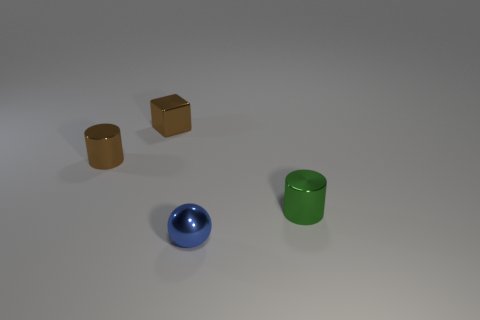Subtract all green cylinders. How many cylinders are left? 1 Subtract 2 cylinders. How many cylinders are left? 0 Add 3 small brown things. How many objects exist? 7 Subtract 1 brown cubes. How many objects are left? 3 Subtract all blue blocks. Subtract all blue cylinders. How many blocks are left? 1 Subtract all red cylinders. How many red cubes are left? 0 Subtract all green rubber cubes. Subtract all small blue objects. How many objects are left? 3 Add 4 tiny brown cubes. How many tiny brown cubes are left? 5 Add 1 brown matte balls. How many brown matte balls exist? 1 